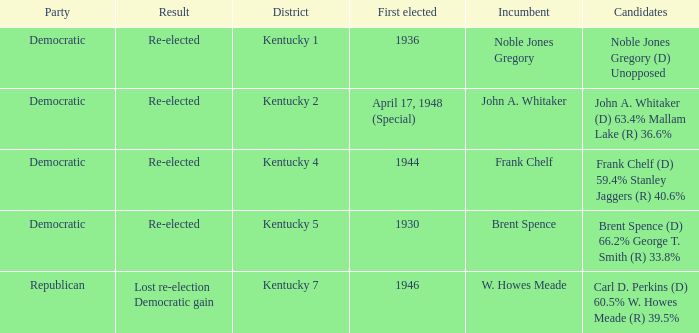Who were the candidates in the Kentucky 4 voting district? Frank Chelf (D) 59.4% Stanley Jaggers (R) 40.6%. 